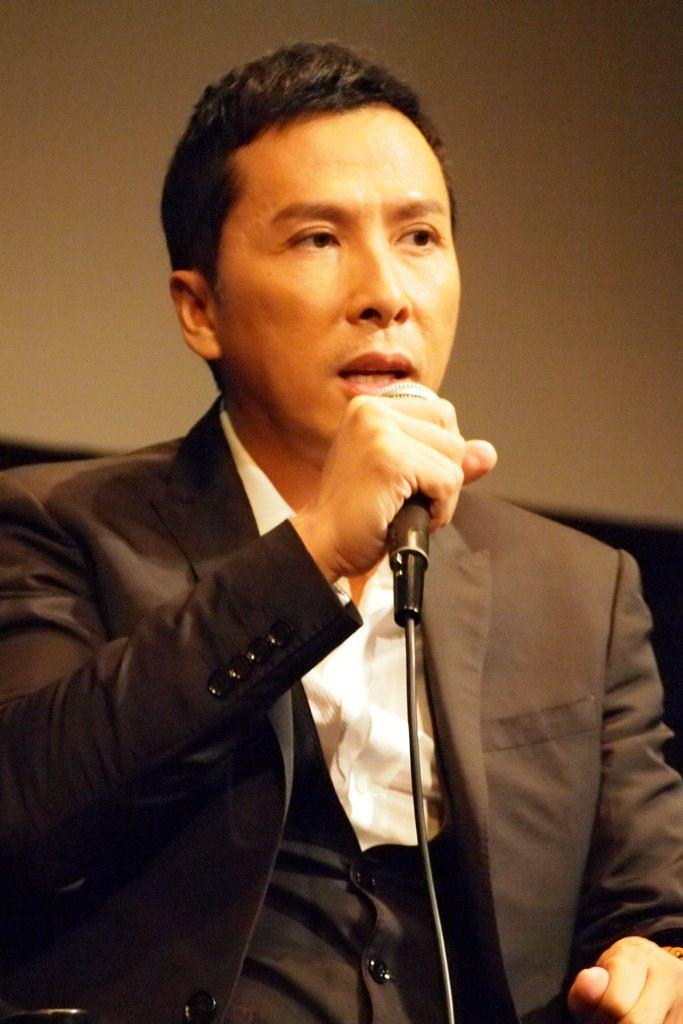What is the main subject of the image? The main subject of the image is a man. What is the man wearing in the image? The man is wearing a black color blazer in the image. What is the man holding in the image? The man is holding a microphone in his hands in the image. What is the man doing in the image? The man is speaking in the image. What can be seen in the background of the image? There is a cream color wall in the background of the image. What type of brass instrument is the man playing in the image? There is no brass instrument present in the image; the man is holding a microphone and speaking. How many people are present in the image, and who are they? There is only one person present in the image, and that is the man. 